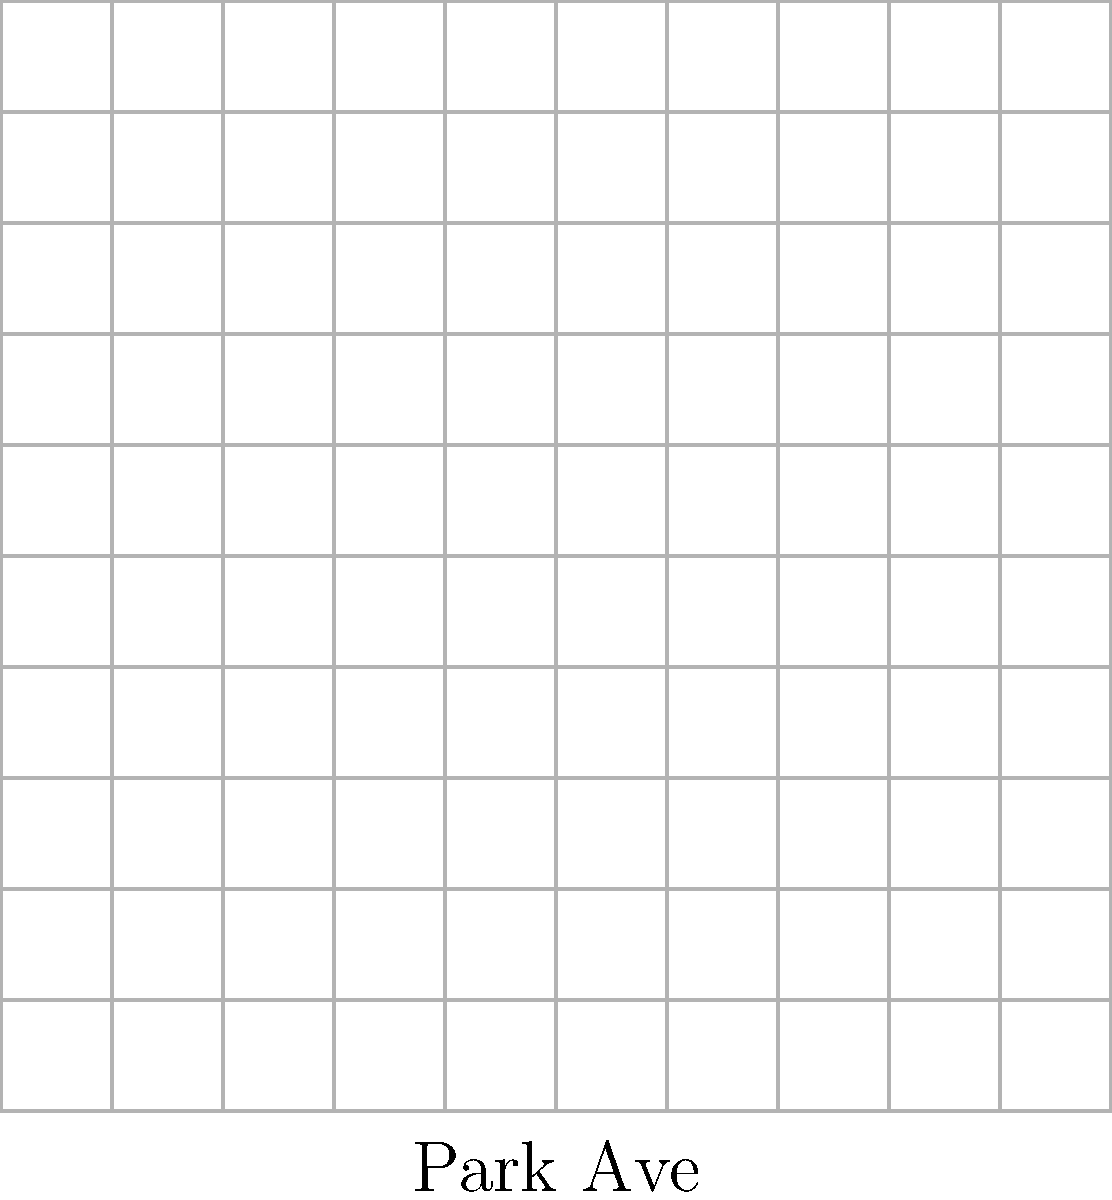On this map of our childhood neighborhood, Sister Klingemann's house is located at coordinates (2, 3) on Park Avenue and Main Street, while your house is at (8, 7). Using the coordinate geometry formula for distance between two points, calculate how many blocks apart you lived from Sister Klingemann. Assume each grid unit represents one block. To find the distance between two points, we can use the distance formula:

$$ d = \sqrt{(x_2 - x_1)^2 + (y_2 - y_1)^2} $$

Where $(x_1, y_1)$ is the location of Sister Klingemann's house (2, 3) and $(x_2, y_2)$ is the location of your house (8, 7).

Let's plug these values into the formula:

$$ d = \sqrt{(8 - 2)^2 + (7 - 3)^2} $$

Simplify the expressions inside the parentheses:

$$ d = \sqrt{6^2 + 4^2} $$

Calculate the squares:

$$ d = \sqrt{36 + 16} $$

Add the numbers under the square root:

$$ d = \sqrt{52} $$

Simplify the square root:

$$ d = 2\sqrt{13} $$

Since each grid unit represents one block, the distance between your houses is $2\sqrt{13}$ blocks.
Answer: $2\sqrt{13}$ blocks 